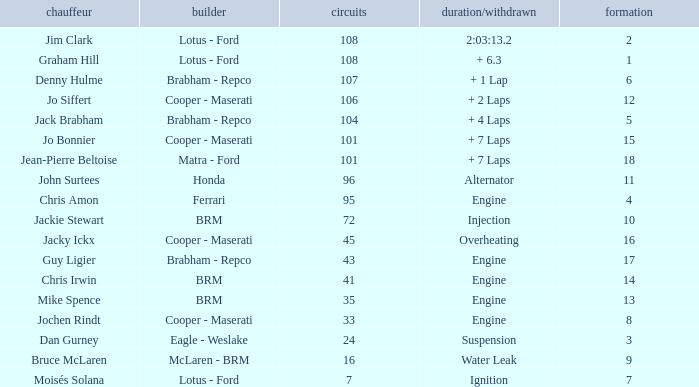What was the constructor when there were 95 laps and a grid less than 15? Ferrari. 